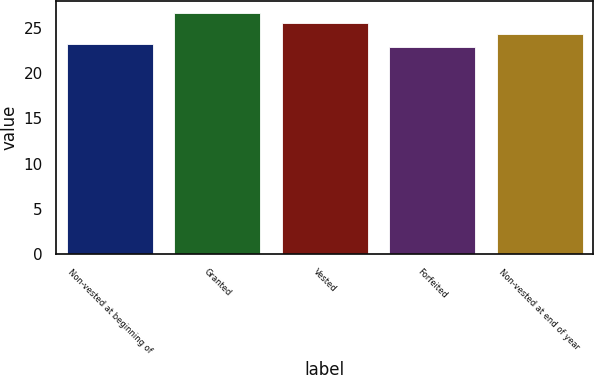<chart> <loc_0><loc_0><loc_500><loc_500><bar_chart><fcel>Non-vested at beginning of<fcel>Granted<fcel>Vested<fcel>Forfeited<fcel>Non-vested at end of year<nl><fcel>23.23<fcel>26.61<fcel>25.54<fcel>22.86<fcel>24.37<nl></chart> 